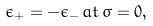Convert formula to latex. <formula><loc_0><loc_0><loc_500><loc_500>\epsilon _ { + } = - \epsilon _ { - } \, a t \, \sigma = 0 ,</formula> 